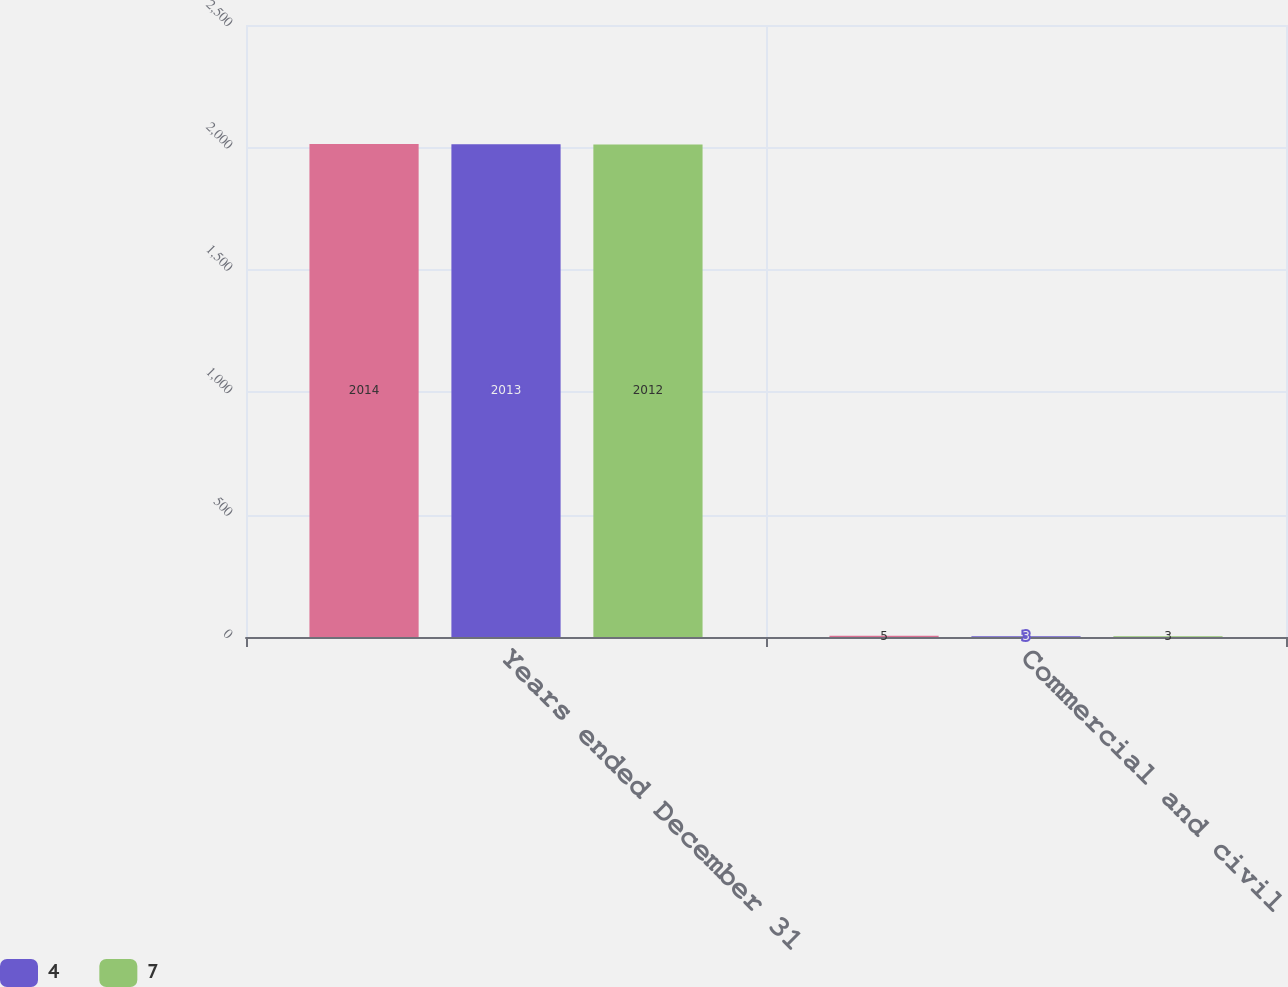Convert chart to OTSL. <chart><loc_0><loc_0><loc_500><loc_500><stacked_bar_chart><ecel><fcel>Years ended December 31<fcel>Commercial and civil<nl><fcel>nan<fcel>2014<fcel>5<nl><fcel>4<fcel>2013<fcel>3<nl><fcel>7<fcel>2012<fcel>3<nl></chart> 